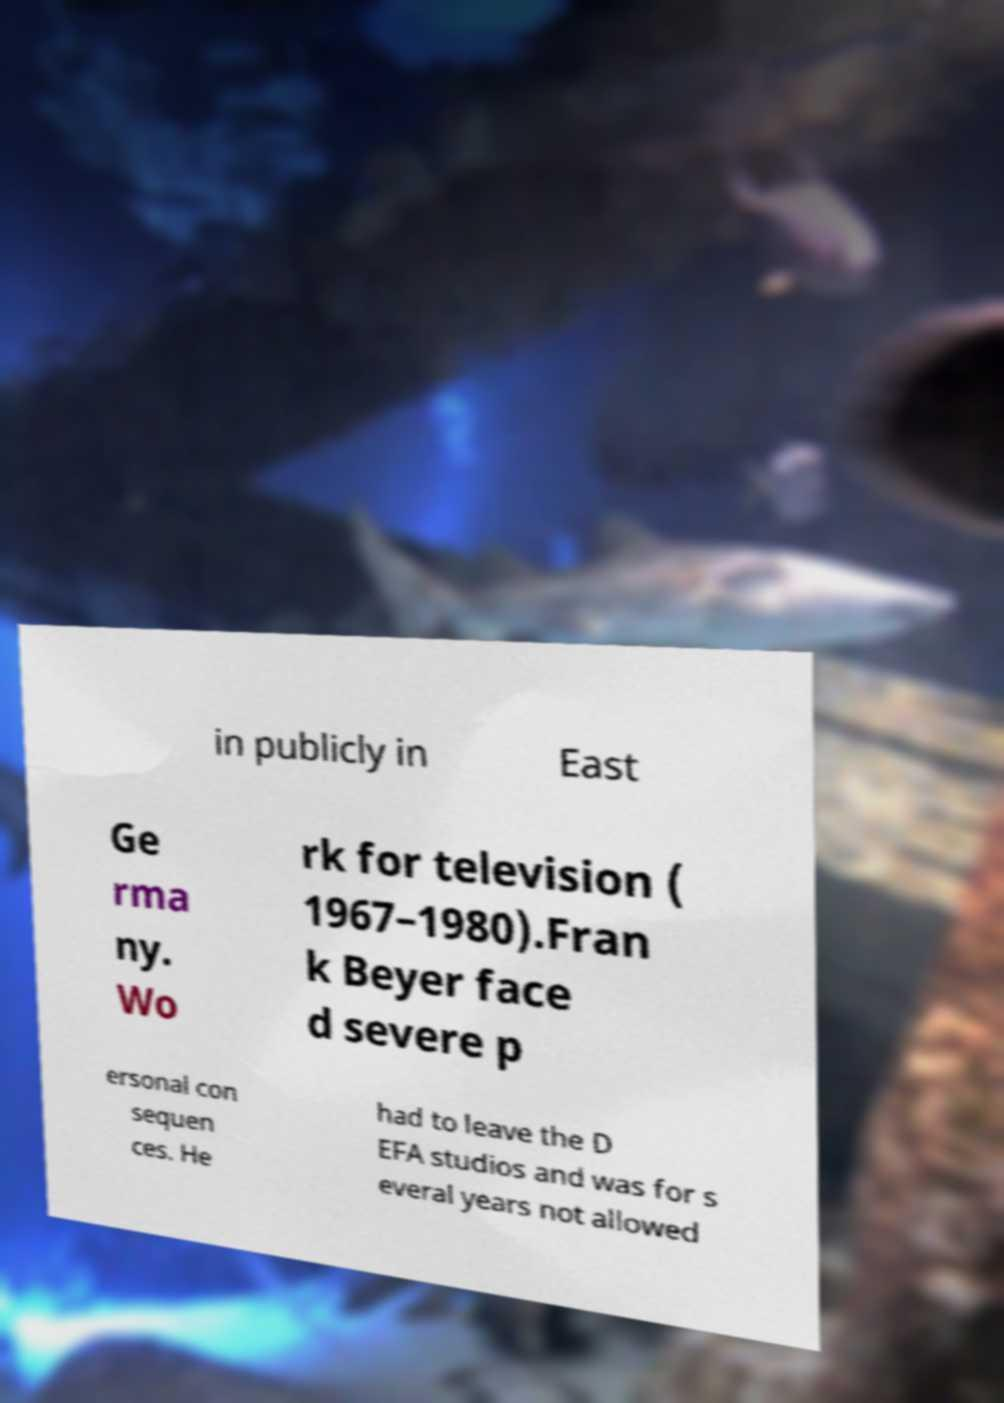What messages or text are displayed in this image? I need them in a readable, typed format. in publicly in East Ge rma ny. Wo rk for television ( 1967–1980).Fran k Beyer face d severe p ersonal con sequen ces. He had to leave the D EFA studios and was for s everal years not allowed 